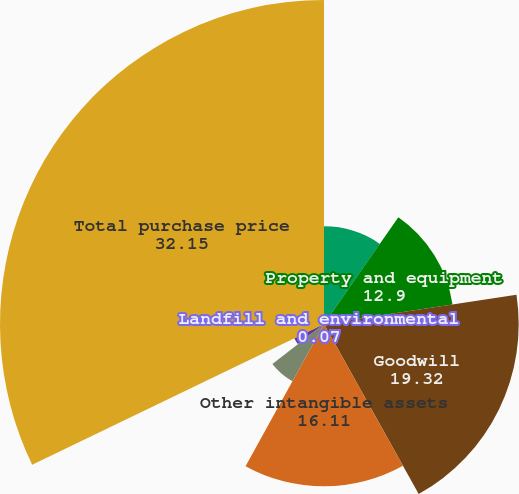<chart> <loc_0><loc_0><loc_500><loc_500><pie_chart><fcel>Accounts and other receivables<fcel>Property and equipment<fcel>Goodwill<fcel>Other intangible assets<fcel>Deferred revenues<fcel>Landfill and environmental<fcel>Long-term debt less current<fcel>Total purchase price<nl><fcel>9.69%<fcel>12.9%<fcel>19.32%<fcel>16.11%<fcel>6.48%<fcel>0.07%<fcel>3.27%<fcel>32.15%<nl></chart> 